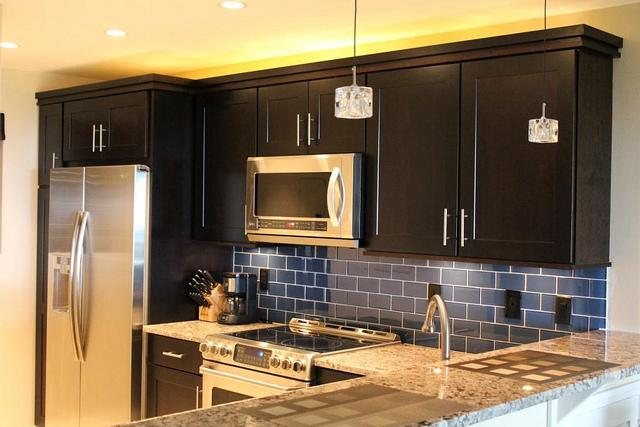What does the item with silver doors regulate?

Choices:
A) humidity
B) bacterial content
C) temperature
D) blood pressure temperature 